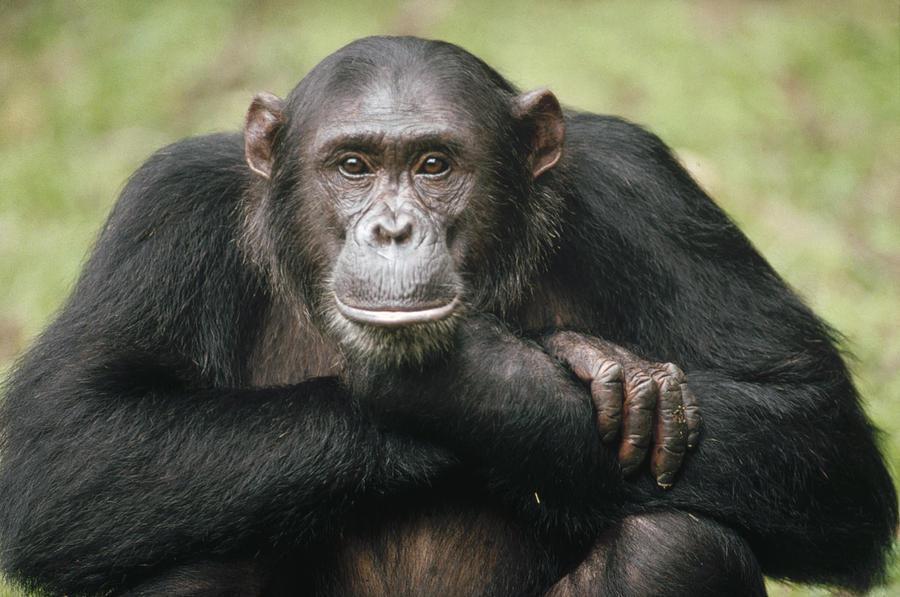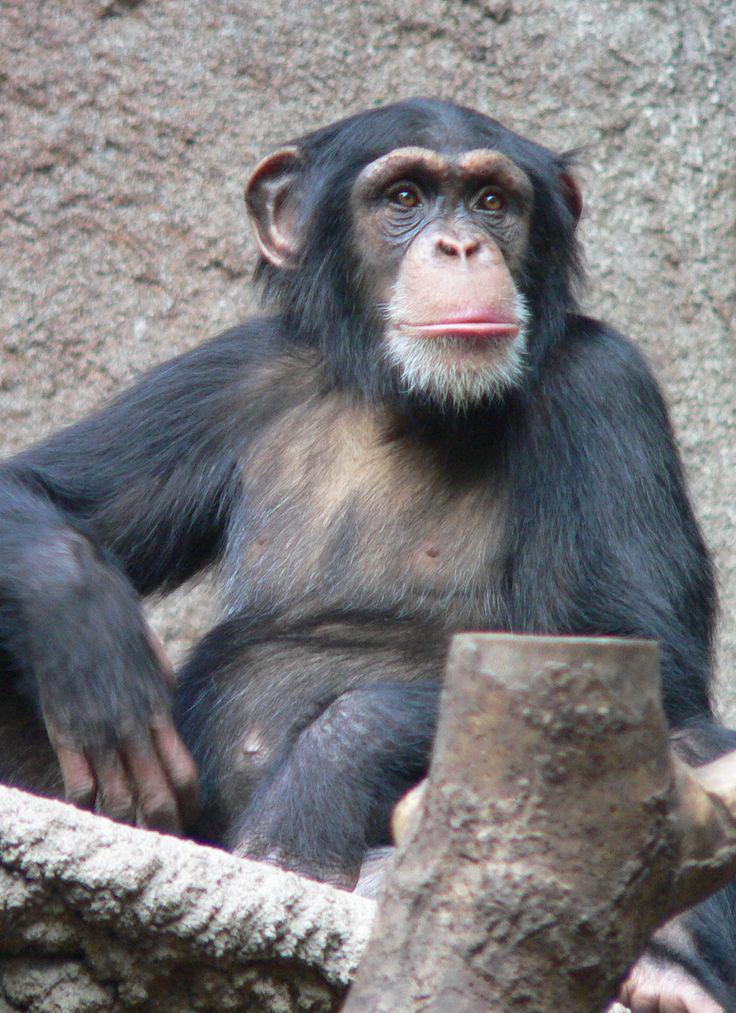The first image is the image on the left, the second image is the image on the right. Analyze the images presented: Is the assertion "There's exactly two chimpanzees." valid? Answer yes or no. Yes. 